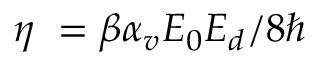Convert formula to latex. <formula><loc_0><loc_0><loc_500><loc_500>\eta = \beta \alpha _ { v } E _ { 0 } E _ { d } / 8 \hbar</formula> 